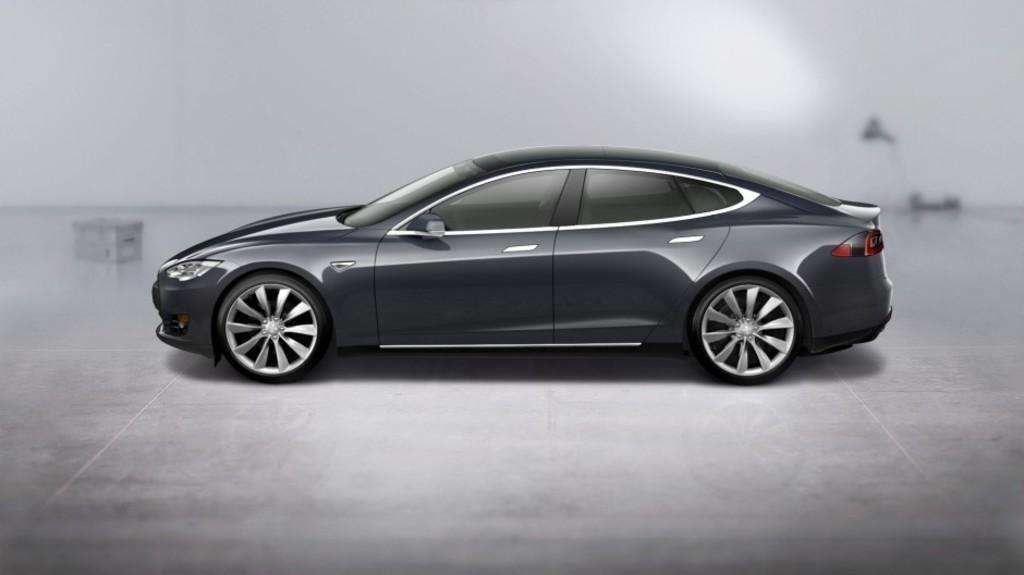What is the color scheme of the image? The image is black and white. What is located at the bottom of the image? There is a floor at the bottom of the image. What can be seen in the background of the image? There is a wall in the background of the image. What is parked in the middle of the image? A car is parked in the middle of the image. Where is the hose connected to in the image? There is no hose present in the image. What type of knowledge is being shared in the image? There is no indication of knowledge being shared in the image; it primarily features a car parked in the middle. 